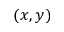Convert formula to latex. <formula><loc_0><loc_0><loc_500><loc_500>( x , y )</formula> 